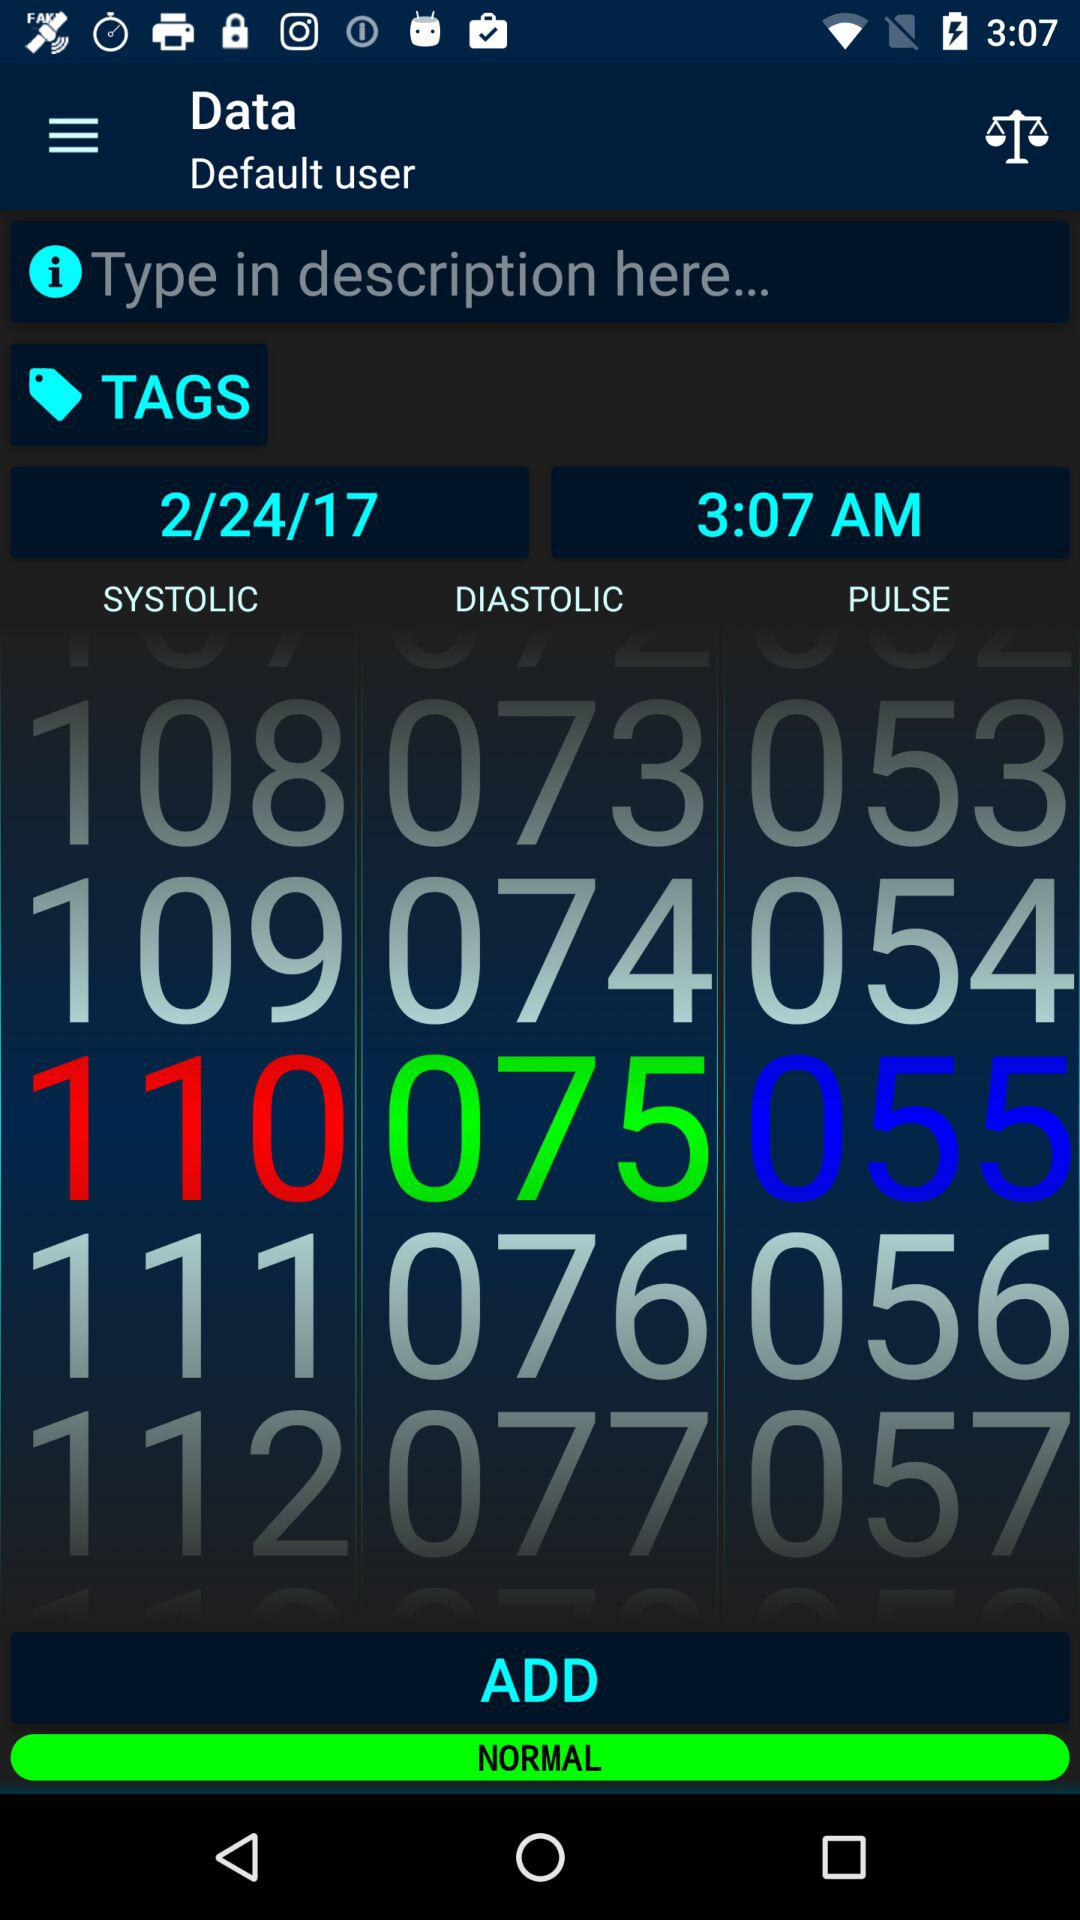Which value is marked normal?
When the provided information is insufficient, respond with <no answer>. <no answer> 